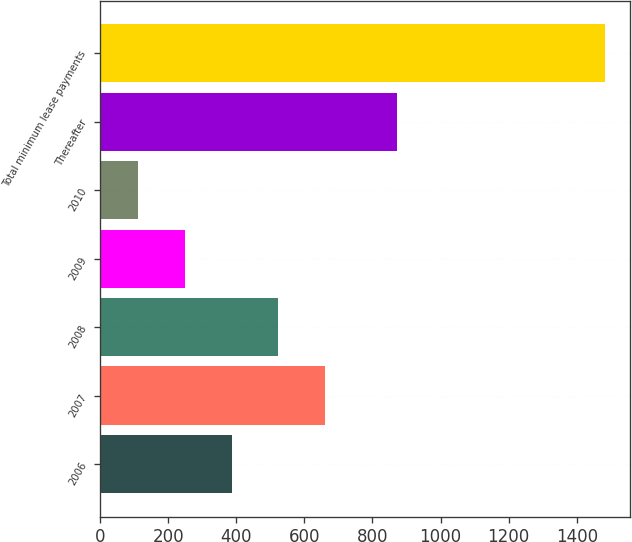Convert chart. <chart><loc_0><loc_0><loc_500><loc_500><bar_chart><fcel>2006<fcel>2007<fcel>2008<fcel>2009<fcel>2010<fcel>Thereafter<fcel>Total minimum lease payments<nl><fcel>386.2<fcel>660.4<fcel>523.3<fcel>249.1<fcel>112<fcel>873<fcel>1483<nl></chart> 